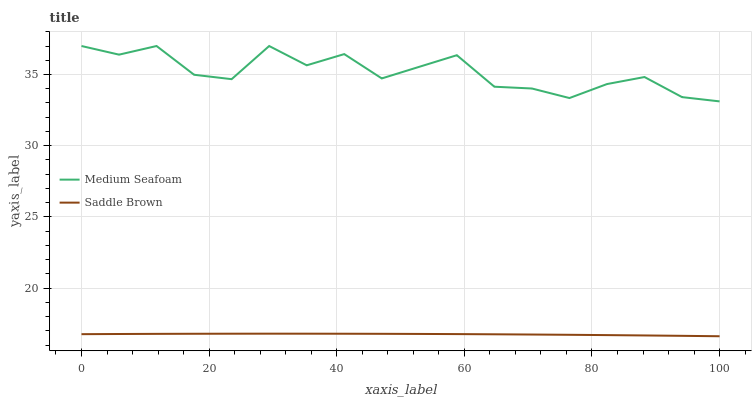Does Saddle Brown have the minimum area under the curve?
Answer yes or no. Yes. Does Medium Seafoam have the maximum area under the curve?
Answer yes or no. Yes. Does Saddle Brown have the maximum area under the curve?
Answer yes or no. No. Is Saddle Brown the smoothest?
Answer yes or no. Yes. Is Medium Seafoam the roughest?
Answer yes or no. Yes. Is Saddle Brown the roughest?
Answer yes or no. No. Does Saddle Brown have the highest value?
Answer yes or no. No. Is Saddle Brown less than Medium Seafoam?
Answer yes or no. Yes. Is Medium Seafoam greater than Saddle Brown?
Answer yes or no. Yes. Does Saddle Brown intersect Medium Seafoam?
Answer yes or no. No. 